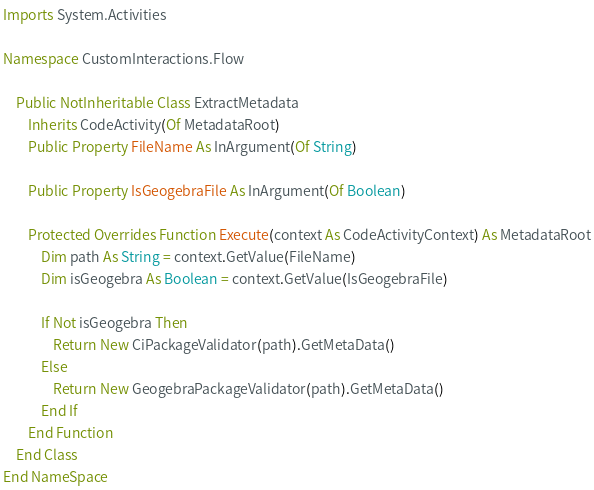Convert code to text. <code><loc_0><loc_0><loc_500><loc_500><_VisualBasic_>Imports System.Activities

Namespace CustomInteractions.Flow

    Public NotInheritable Class ExtractMetadata
        Inherits CodeActivity(Of MetadataRoot)
        Public Property FileName As InArgument(Of String)

        Public Property IsGeogebraFile As InArgument(Of Boolean)

        Protected Overrides Function Execute(context As CodeActivityContext) As MetadataRoot
            Dim path As String = context.GetValue(FileName)
            Dim isGeogebra As Boolean = context.GetValue(IsGeogebraFile)

            If Not isGeogebra Then
                Return New CiPackageValidator(path).GetMetaData()
            Else
                Return New GeogebraPackageValidator(path).GetMetaData()
            End If
        End Function
    End Class
End NameSpace</code> 